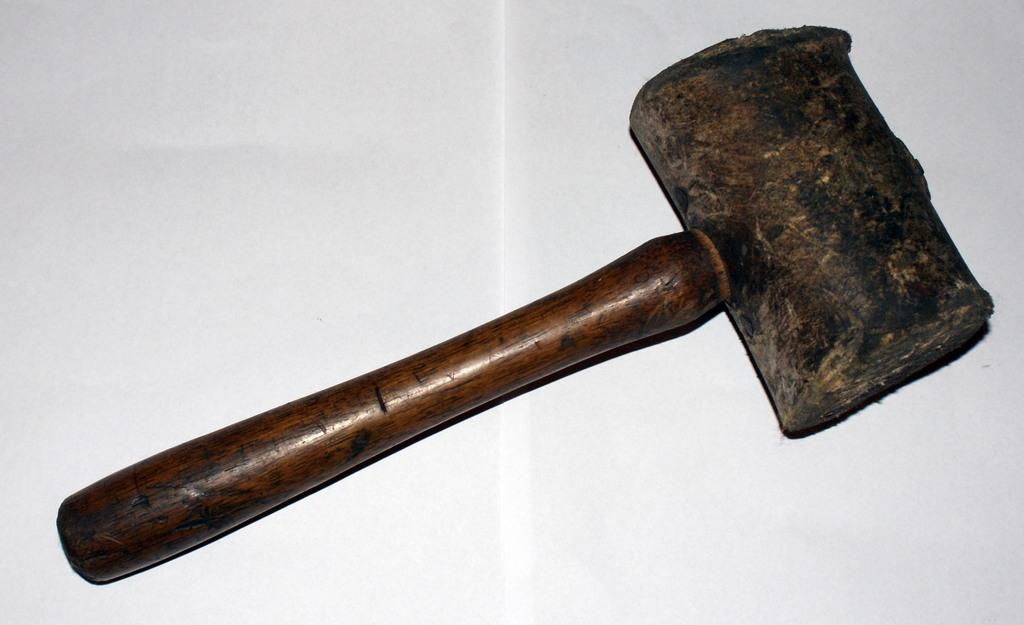What object can be seen in the image? There is a hammer in the image. What is the color of the surface the hammer is on? The hammer is on a white surface. What is the opinion of the hammer about the amusement park in the image? There is no amusement park or indication of the hammer's opinion in the image. How many baskets are visible in the image? There are no baskets present in the image. 